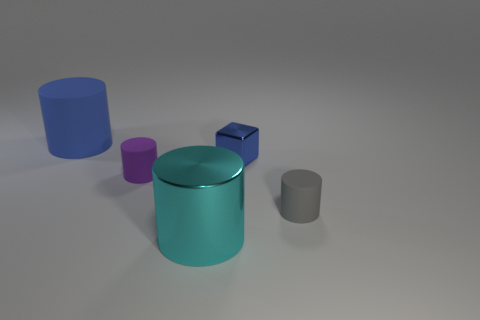Subtract all cyan cylinders. How many cylinders are left? 3 Subtract all blue cylinders. How many cylinders are left? 3 Add 3 big blue rubber things. How many objects exist? 8 Subtract all cylinders. How many objects are left? 1 Add 1 tiny gray rubber cubes. How many tiny gray rubber cubes exist? 1 Subtract 0 blue spheres. How many objects are left? 5 Subtract all red cubes. Subtract all gray spheres. How many cubes are left? 1 Subtract all large metallic cylinders. Subtract all tiny metal cubes. How many objects are left? 3 Add 2 gray objects. How many gray objects are left? 3 